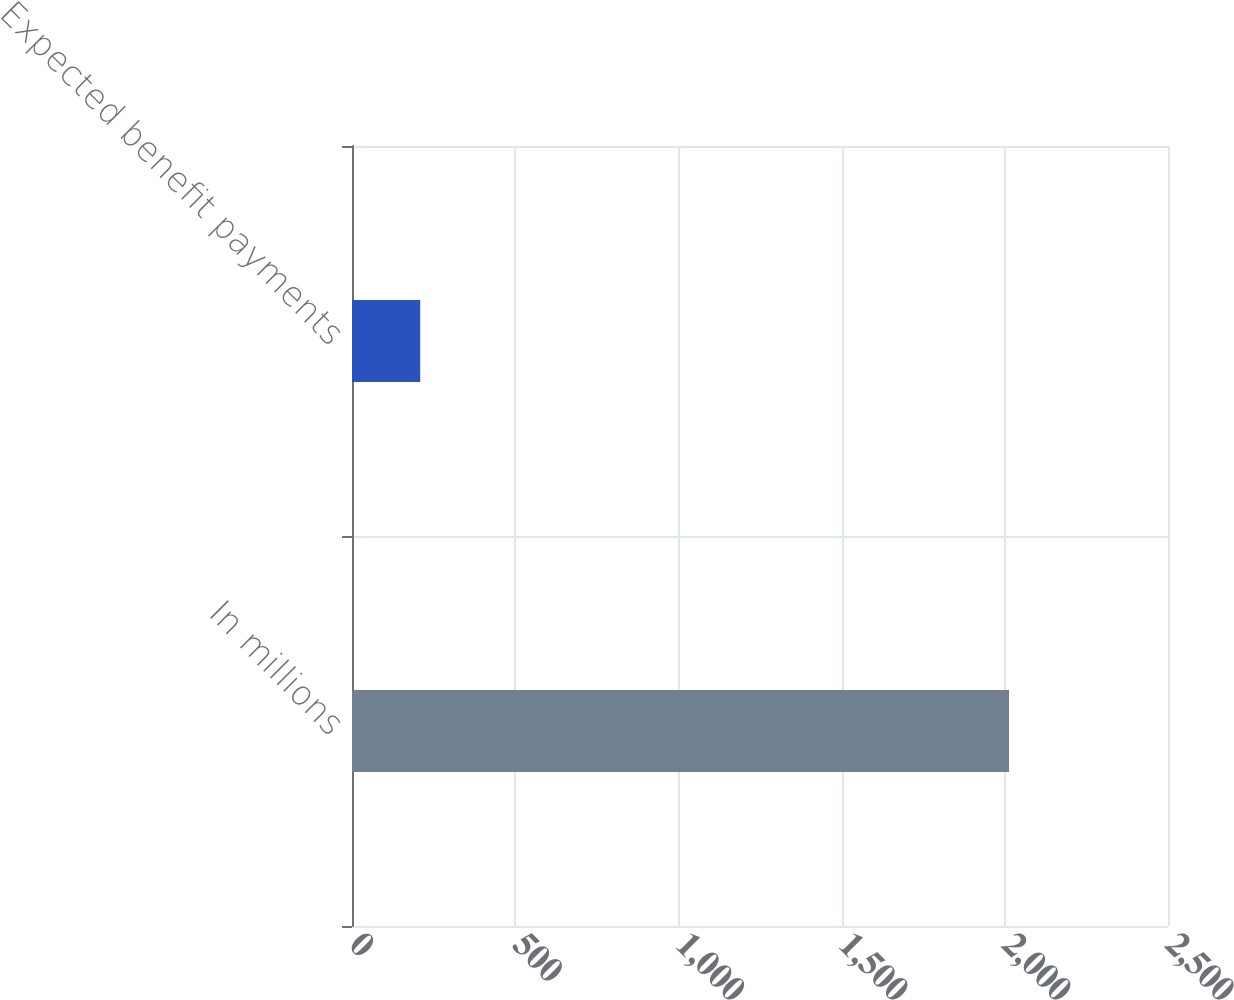<chart> <loc_0><loc_0><loc_500><loc_500><bar_chart><fcel>In millions<fcel>Expected benefit payments<nl><fcel>2013<fcel>209<nl></chart> 